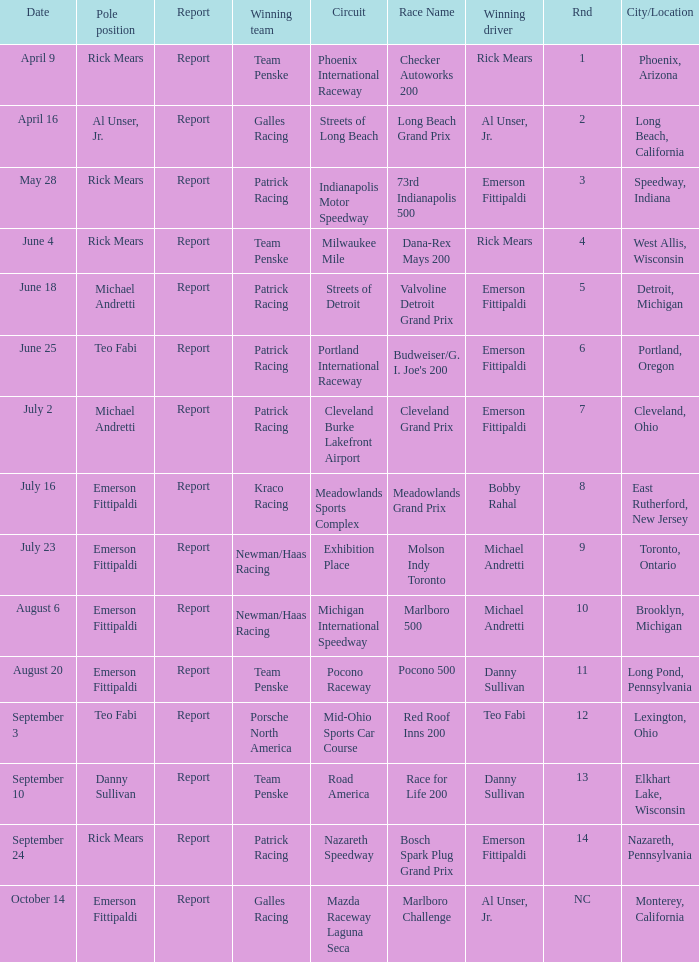Help me parse the entirety of this table. {'header': ['Date', 'Pole position', 'Report', 'Winning team', 'Circuit', 'Race Name', 'Winning driver', 'Rnd', 'City/Location'], 'rows': [['April 9', 'Rick Mears', 'Report', 'Team Penske', 'Phoenix International Raceway', 'Checker Autoworks 200', 'Rick Mears', '1', 'Phoenix, Arizona'], ['April 16', 'Al Unser, Jr.', 'Report', 'Galles Racing', 'Streets of Long Beach', 'Long Beach Grand Prix', 'Al Unser, Jr.', '2', 'Long Beach, California'], ['May 28', 'Rick Mears', 'Report', 'Patrick Racing', 'Indianapolis Motor Speedway', '73rd Indianapolis 500', 'Emerson Fittipaldi', '3', 'Speedway, Indiana'], ['June 4', 'Rick Mears', 'Report', 'Team Penske', 'Milwaukee Mile', 'Dana-Rex Mays 200', 'Rick Mears', '4', 'West Allis, Wisconsin'], ['June 18', 'Michael Andretti', 'Report', 'Patrick Racing', 'Streets of Detroit', 'Valvoline Detroit Grand Prix', 'Emerson Fittipaldi', '5', 'Detroit, Michigan'], ['June 25', 'Teo Fabi', 'Report', 'Patrick Racing', 'Portland International Raceway', "Budweiser/G. I. Joe's 200", 'Emerson Fittipaldi', '6', 'Portland, Oregon'], ['July 2', 'Michael Andretti', 'Report', 'Patrick Racing', 'Cleveland Burke Lakefront Airport', 'Cleveland Grand Prix', 'Emerson Fittipaldi', '7', 'Cleveland, Ohio'], ['July 16', 'Emerson Fittipaldi', 'Report', 'Kraco Racing', 'Meadowlands Sports Complex', 'Meadowlands Grand Prix', 'Bobby Rahal', '8', 'East Rutherford, New Jersey'], ['July 23', 'Emerson Fittipaldi', 'Report', 'Newman/Haas Racing', 'Exhibition Place', 'Molson Indy Toronto', 'Michael Andretti', '9', 'Toronto, Ontario'], ['August 6', 'Emerson Fittipaldi', 'Report', 'Newman/Haas Racing', 'Michigan International Speedway', 'Marlboro 500', 'Michael Andretti', '10', 'Brooklyn, Michigan'], ['August 20', 'Emerson Fittipaldi', 'Report', 'Team Penske', 'Pocono Raceway', 'Pocono 500', 'Danny Sullivan', '11', 'Long Pond, Pennsylvania'], ['September 3', 'Teo Fabi', 'Report', 'Porsche North America', 'Mid-Ohio Sports Car Course', 'Red Roof Inns 200', 'Teo Fabi', '12', 'Lexington, Ohio'], ['September 10', 'Danny Sullivan', 'Report', 'Team Penske', 'Road America', 'Race for Life 200', 'Danny Sullivan', '13', 'Elkhart Lake, Wisconsin'], ['September 24', 'Rick Mears', 'Report', 'Patrick Racing', 'Nazareth Speedway', 'Bosch Spark Plug Grand Prix', 'Emerson Fittipaldi', '14', 'Nazareth, Pennsylvania'], ['October 14', 'Emerson Fittipaldi', 'Report', 'Galles Racing', 'Mazda Raceway Laguna Seca', 'Marlboro Challenge', 'Al Unser, Jr.', 'NC', 'Monterey, California']]} How many winning drivers were the for the rnd equalling 5? 1.0. 